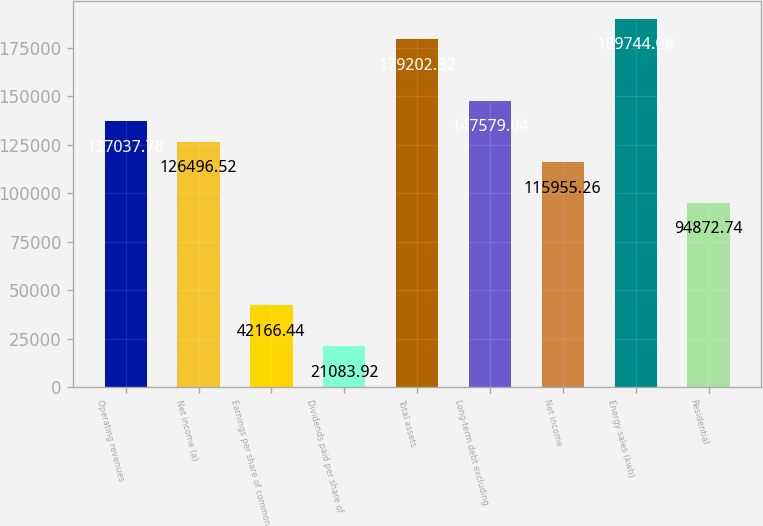<chart> <loc_0><loc_0><loc_500><loc_500><bar_chart><fcel>Operating revenues<fcel>Net income (a)<fcel>Earnings per share of common<fcel>Dividends paid per share of<fcel>Total assets<fcel>Long-term debt excluding<fcel>Net income<fcel>Energy sales (kwh)<fcel>Residential<nl><fcel>137038<fcel>126497<fcel>42166.4<fcel>21083.9<fcel>179203<fcel>147579<fcel>115955<fcel>189744<fcel>94872.7<nl></chart> 